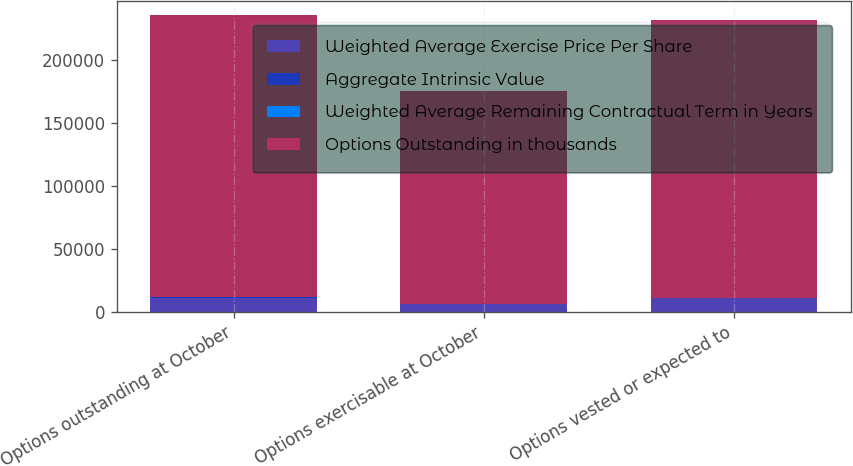<chart> <loc_0><loc_0><loc_500><loc_500><stacked_bar_chart><ecel><fcel>Options outstanding at October<fcel>Options exercisable at October<fcel>Options vested or expected to<nl><fcel>Weighted Average Exercise Price Per Share<fcel>11704<fcel>6577<fcel>11321<nl><fcel>Aggregate Intrinsic Value<fcel>44.43<fcel>37.9<fcel>44.09<nl><fcel>Weighted Average Remaining Contractual Term in Years<fcel>6<fcel>4.5<fcel>6<nl><fcel>Options Outstanding in thousands<fcel>223611<fcel>168549<fcel>220085<nl></chart> 